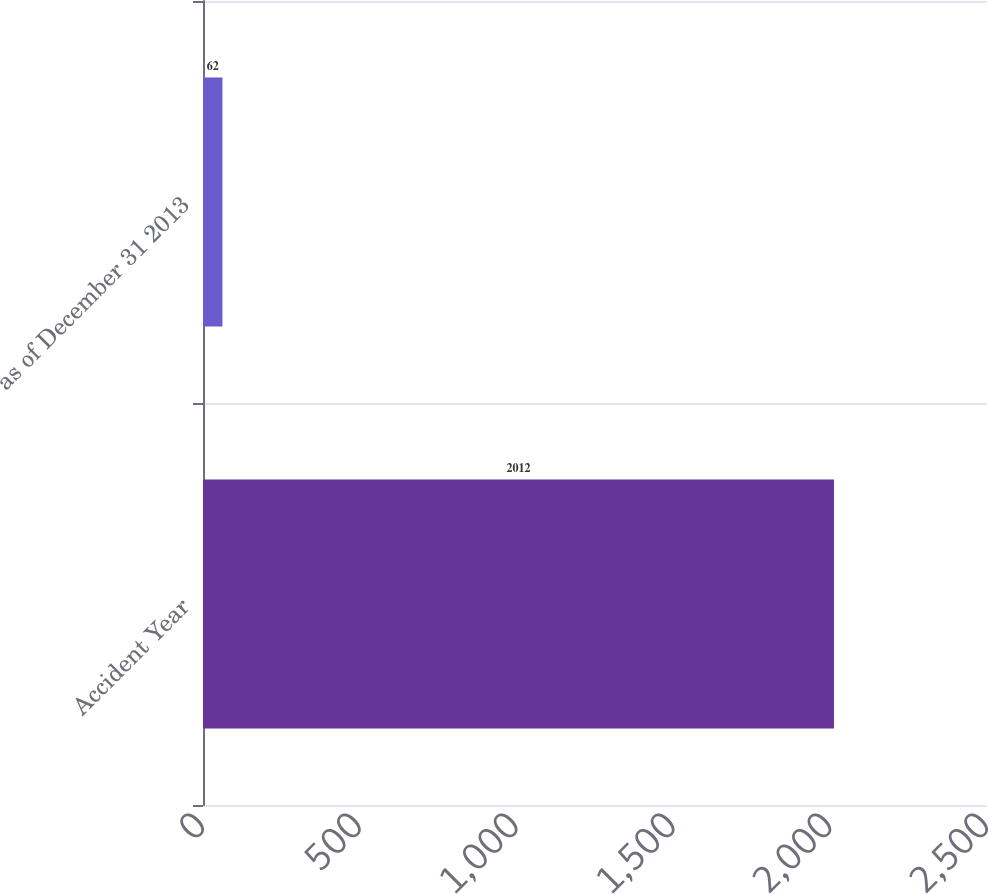Convert chart to OTSL. <chart><loc_0><loc_0><loc_500><loc_500><bar_chart><fcel>Accident Year<fcel>as of December 31 2013<nl><fcel>2012<fcel>62<nl></chart> 